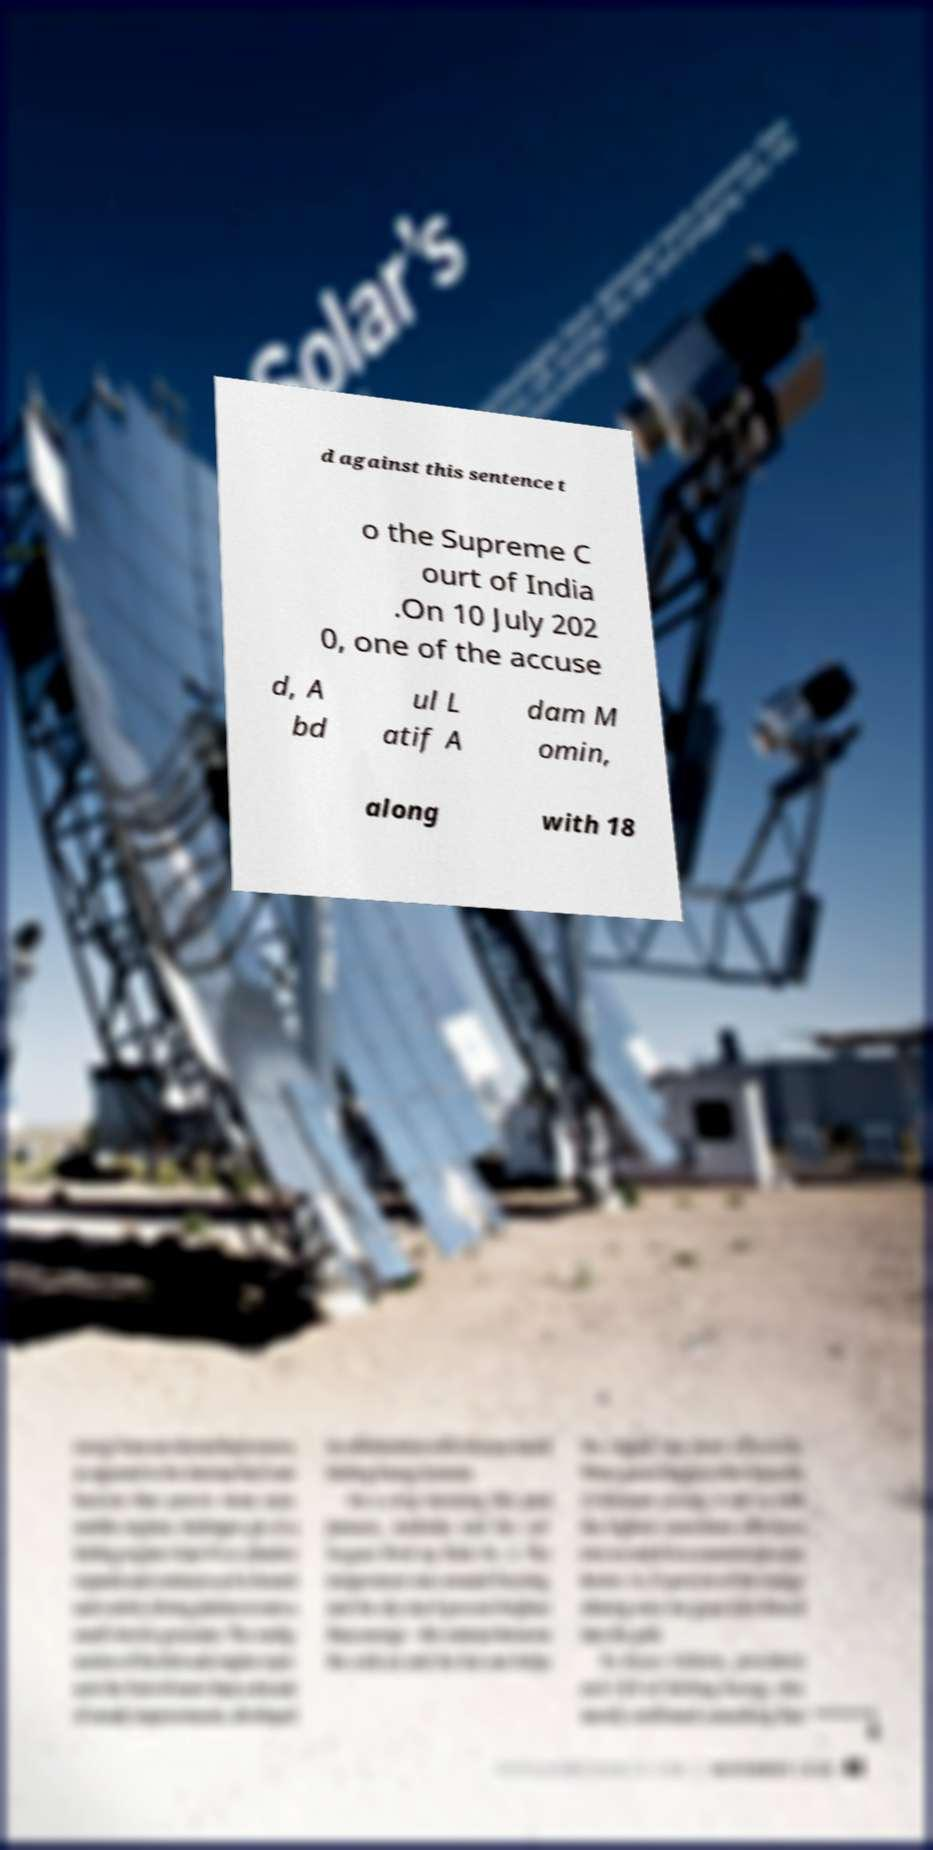What messages or text are displayed in this image? I need them in a readable, typed format. d against this sentence t o the Supreme C ourt of India .On 10 July 202 0, one of the accuse d, A bd ul L atif A dam M omin, along with 18 